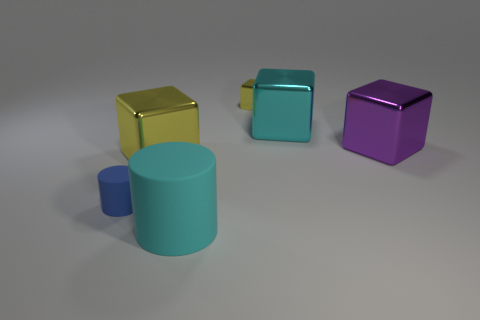Add 2 yellow matte things. How many objects exist? 8 Subtract all cylinders. How many objects are left? 4 Subtract 0 brown cylinders. How many objects are left? 6 Subtract all small cyan cylinders. Subtract all yellow cubes. How many objects are left? 4 Add 3 blue rubber objects. How many blue rubber objects are left? 4 Add 2 big purple blocks. How many big purple blocks exist? 3 